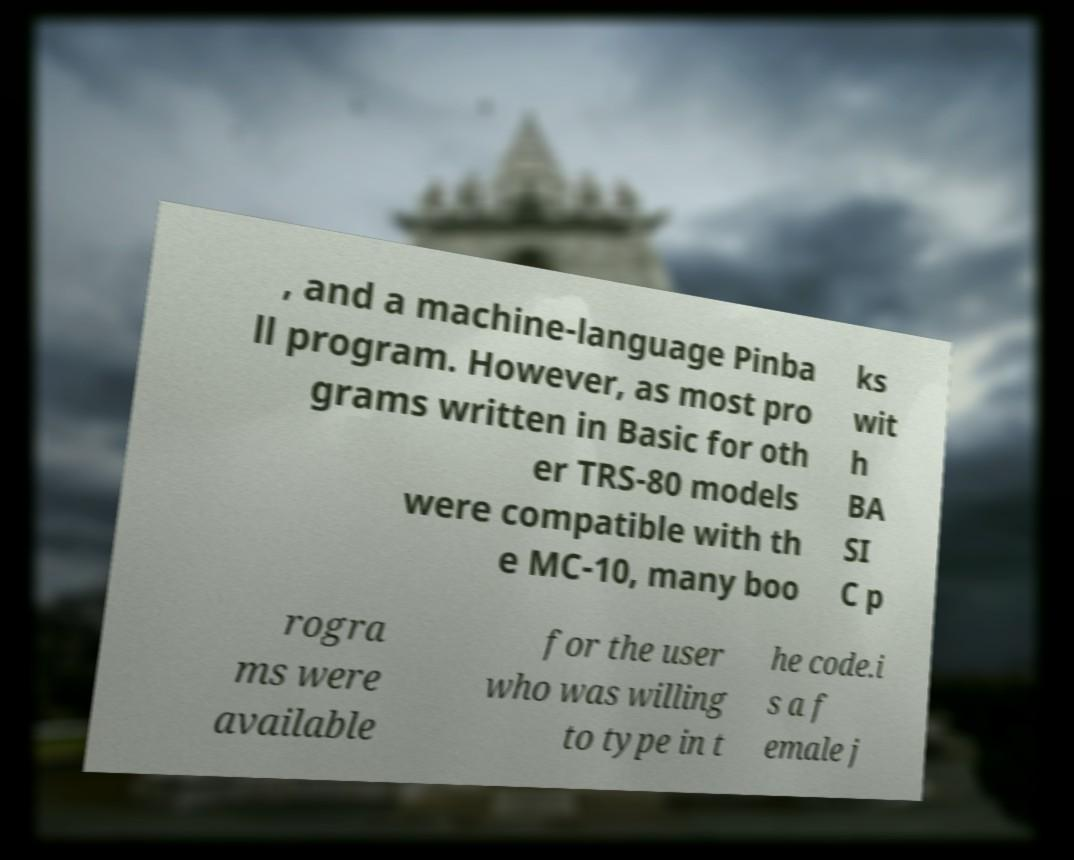What messages or text are displayed in this image? I need them in a readable, typed format. , and a machine-language Pinba ll program. However, as most pro grams written in Basic for oth er TRS-80 models were compatible with th e MC-10, many boo ks wit h BA SI C p rogra ms were available for the user who was willing to type in t he code.i s a f emale j 